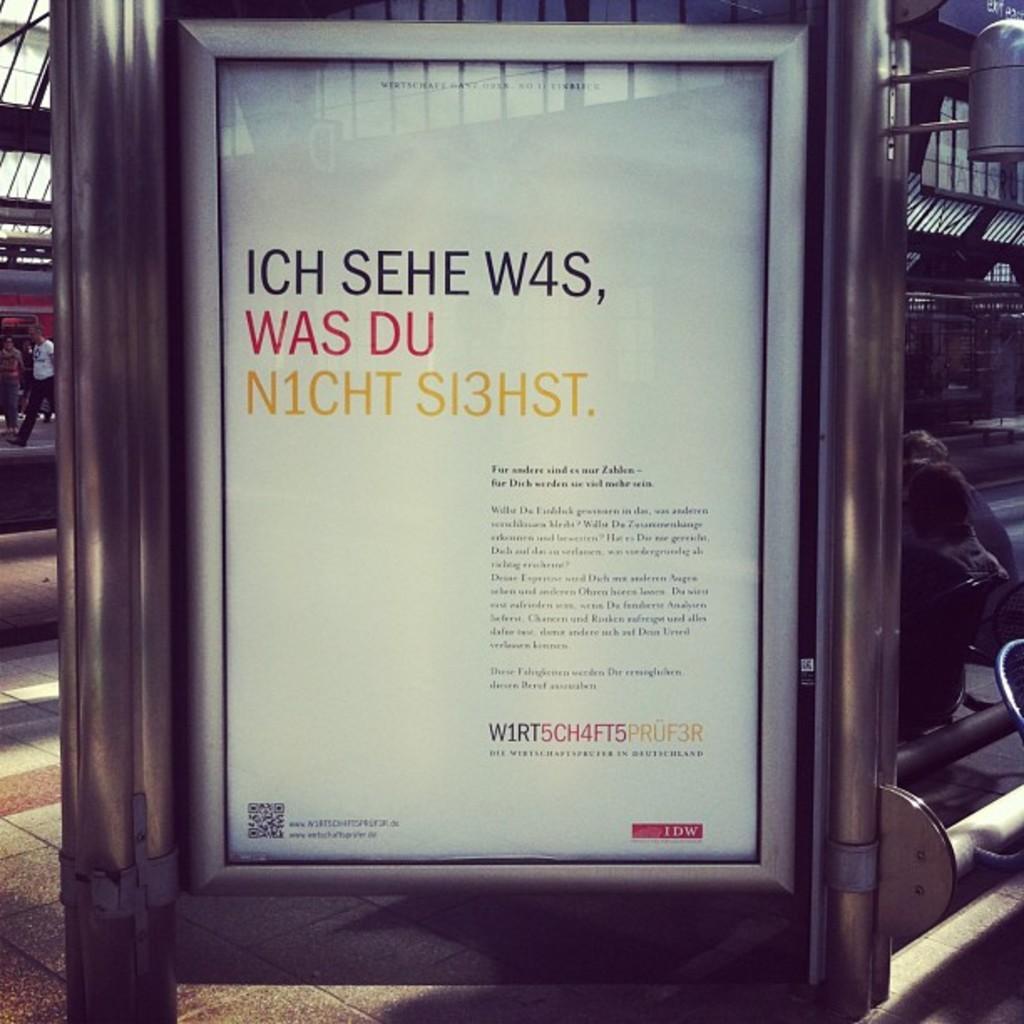Please provide a concise description of this image. In this picture there is a board on the pole and there is a text on the board. On the right side of the image there are two persons sitting on the chairs. On the left side of the image there are two persons walking and there is a train. At the top there is a roof. 